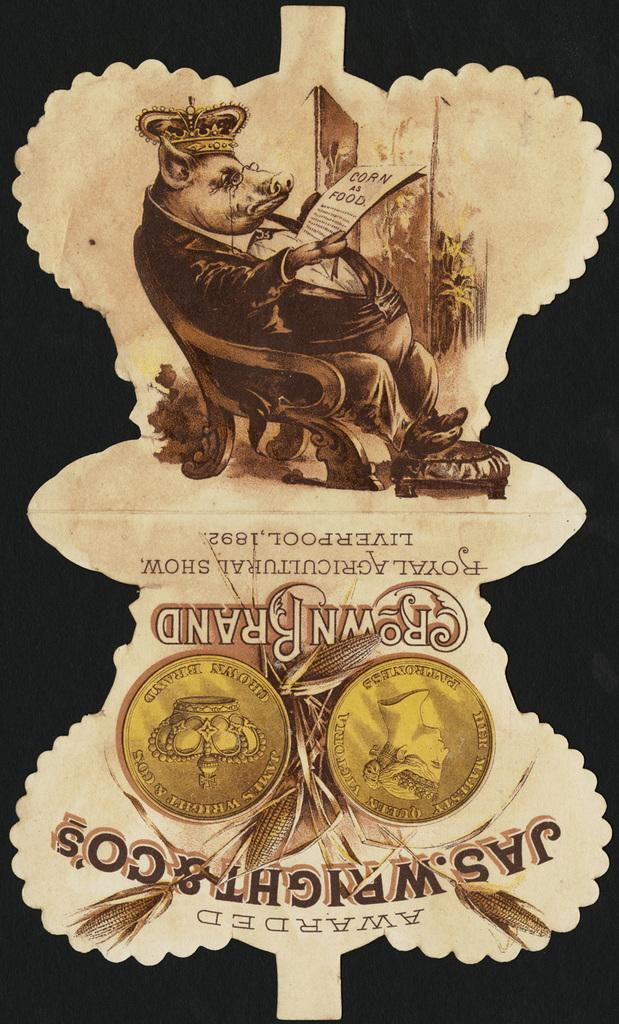<image>
Render a clear and concise summary of the photo. An advertisement for Jas. Wright & Co's portrays a pig as royalty. 